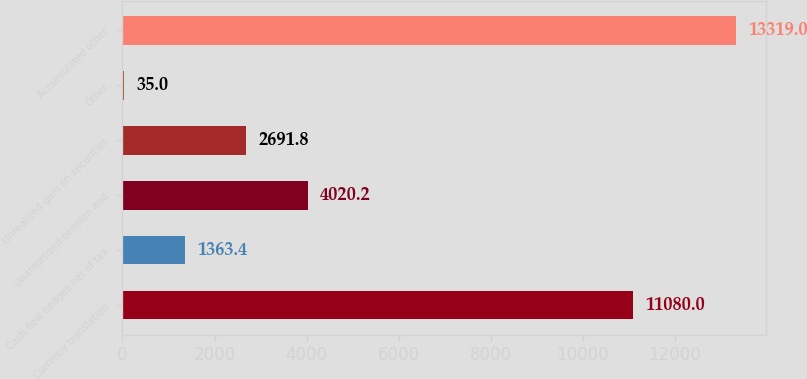<chart> <loc_0><loc_0><loc_500><loc_500><bar_chart><fcel>Currency translation<fcel>Cash flow hedges net of tax<fcel>Unamortized pension and<fcel>Unrealized gain on securities<fcel>Other<fcel>Accumulated other<nl><fcel>11080<fcel>1363.4<fcel>4020.2<fcel>2691.8<fcel>35<fcel>13319<nl></chart> 